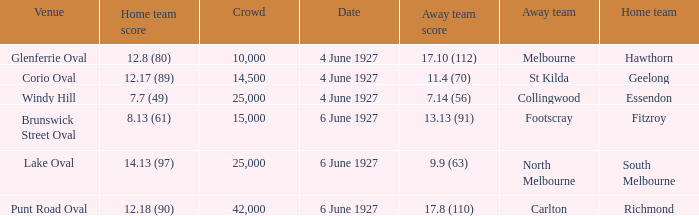Which team was at Corio Oval on 4 June 1927? St Kilda. Can you parse all the data within this table? {'header': ['Venue', 'Home team score', 'Crowd', 'Date', 'Away team score', 'Away team', 'Home team'], 'rows': [['Glenferrie Oval', '12.8 (80)', '10,000', '4 June 1927', '17.10 (112)', 'Melbourne', 'Hawthorn'], ['Corio Oval', '12.17 (89)', '14,500', '4 June 1927', '11.4 (70)', 'St Kilda', 'Geelong'], ['Windy Hill', '7.7 (49)', '25,000', '4 June 1927', '7.14 (56)', 'Collingwood', 'Essendon'], ['Brunswick Street Oval', '8.13 (61)', '15,000', '6 June 1927', '13.13 (91)', 'Footscray', 'Fitzroy'], ['Lake Oval', '14.13 (97)', '25,000', '6 June 1927', '9.9 (63)', 'North Melbourne', 'South Melbourne'], ['Punt Road Oval', '12.18 (90)', '42,000', '6 June 1927', '17.8 (110)', 'Carlton', 'Richmond']]} 